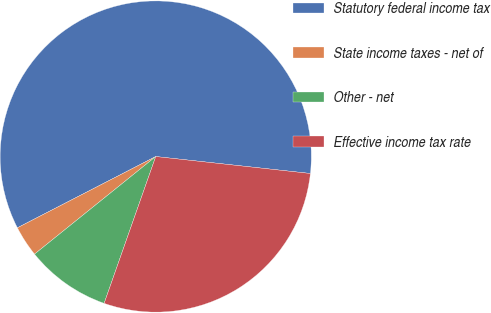Convert chart. <chart><loc_0><loc_0><loc_500><loc_500><pie_chart><fcel>Statutory federal income tax<fcel>State income taxes - net of<fcel>Other - net<fcel>Effective income tax rate<nl><fcel>59.31%<fcel>3.22%<fcel>8.83%<fcel>28.64%<nl></chart> 